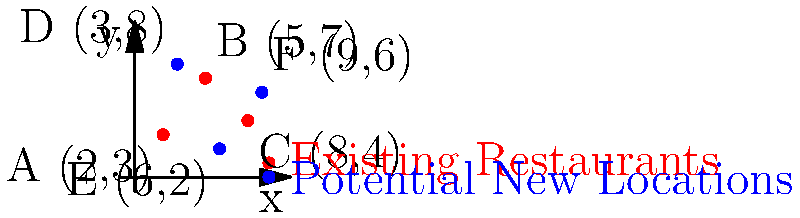As a business banker specializing in restaurant expansion, you're analyzing potential new locations for a client's growing chain. The map shows existing restaurants (red dots) at coordinates A(2,3), B(5,7), and C(8,4), and potential new locations (blue dots) at D(3,8), E(6,2), and F(9,6). To minimize cannibalization, you want to choose the new location that maximizes the minimum distance from any existing restaurant. Which new location (D, E, or F) should you recommend, and what is this minimum distance (rounded to two decimal places)? To solve this problem, we need to:

1. Calculate the distances between each potential new location and all existing restaurants.
2. Find the minimum distance for each potential location.
3. Compare these minimum distances and choose the largest one.

Let's calculate using the distance formula: $d = \sqrt{(x_2-x_1)^2 + (y_2-y_1)^2}$

For location D(3,8):
- Distance to A: $\sqrt{(3-2)^2 + (8-3)^2} = \sqrt{26} \approx 5.10$
- Distance to B: $\sqrt{(3-5)^2 + (8-7)^2} = \sqrt{5} \approx 2.24$
- Distance to C: $\sqrt{(3-8)^2 + (8-4)^2} = \sqrt{41} \approx 6.40$
Minimum distance for D: 2.24

For location E(6,2):
- Distance to A: $\sqrt{(6-2)^2 + (2-3)^2} = \sqrt{17} \approx 4.12$
- Distance to B: $\sqrt{(6-5)^2 + (2-7)^2} = \sqrt{26} \approx 5.10$
- Distance to C: $\sqrt{(6-8)^2 + (2-4)^2} = \sqrt{8} \approx 2.83$
Minimum distance for E: 2.83

For location F(9,6):
- Distance to A: $\sqrt{(9-2)^2 + (6-3)^2} = \sqrt{58} \approx 7.62$
- Distance to B: $\sqrt{(9-5)^2 + (6-7)^2} = \sqrt{17} \approx 4.12$
- Distance to C: $\sqrt{(9-8)^2 + (6-4)^2} = \sqrt{5} \approx 2.24$
Minimum distance for F: 2.24

The largest minimum distance is 2.83, corresponding to location E.
Answer: Location E, 2.83 